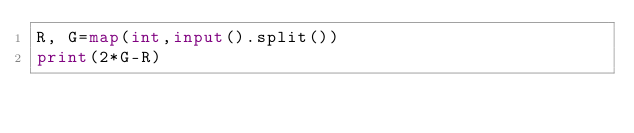Convert code to text. <code><loc_0><loc_0><loc_500><loc_500><_Python_>R, G=map(int,input().split())
print(2*G-R)</code> 